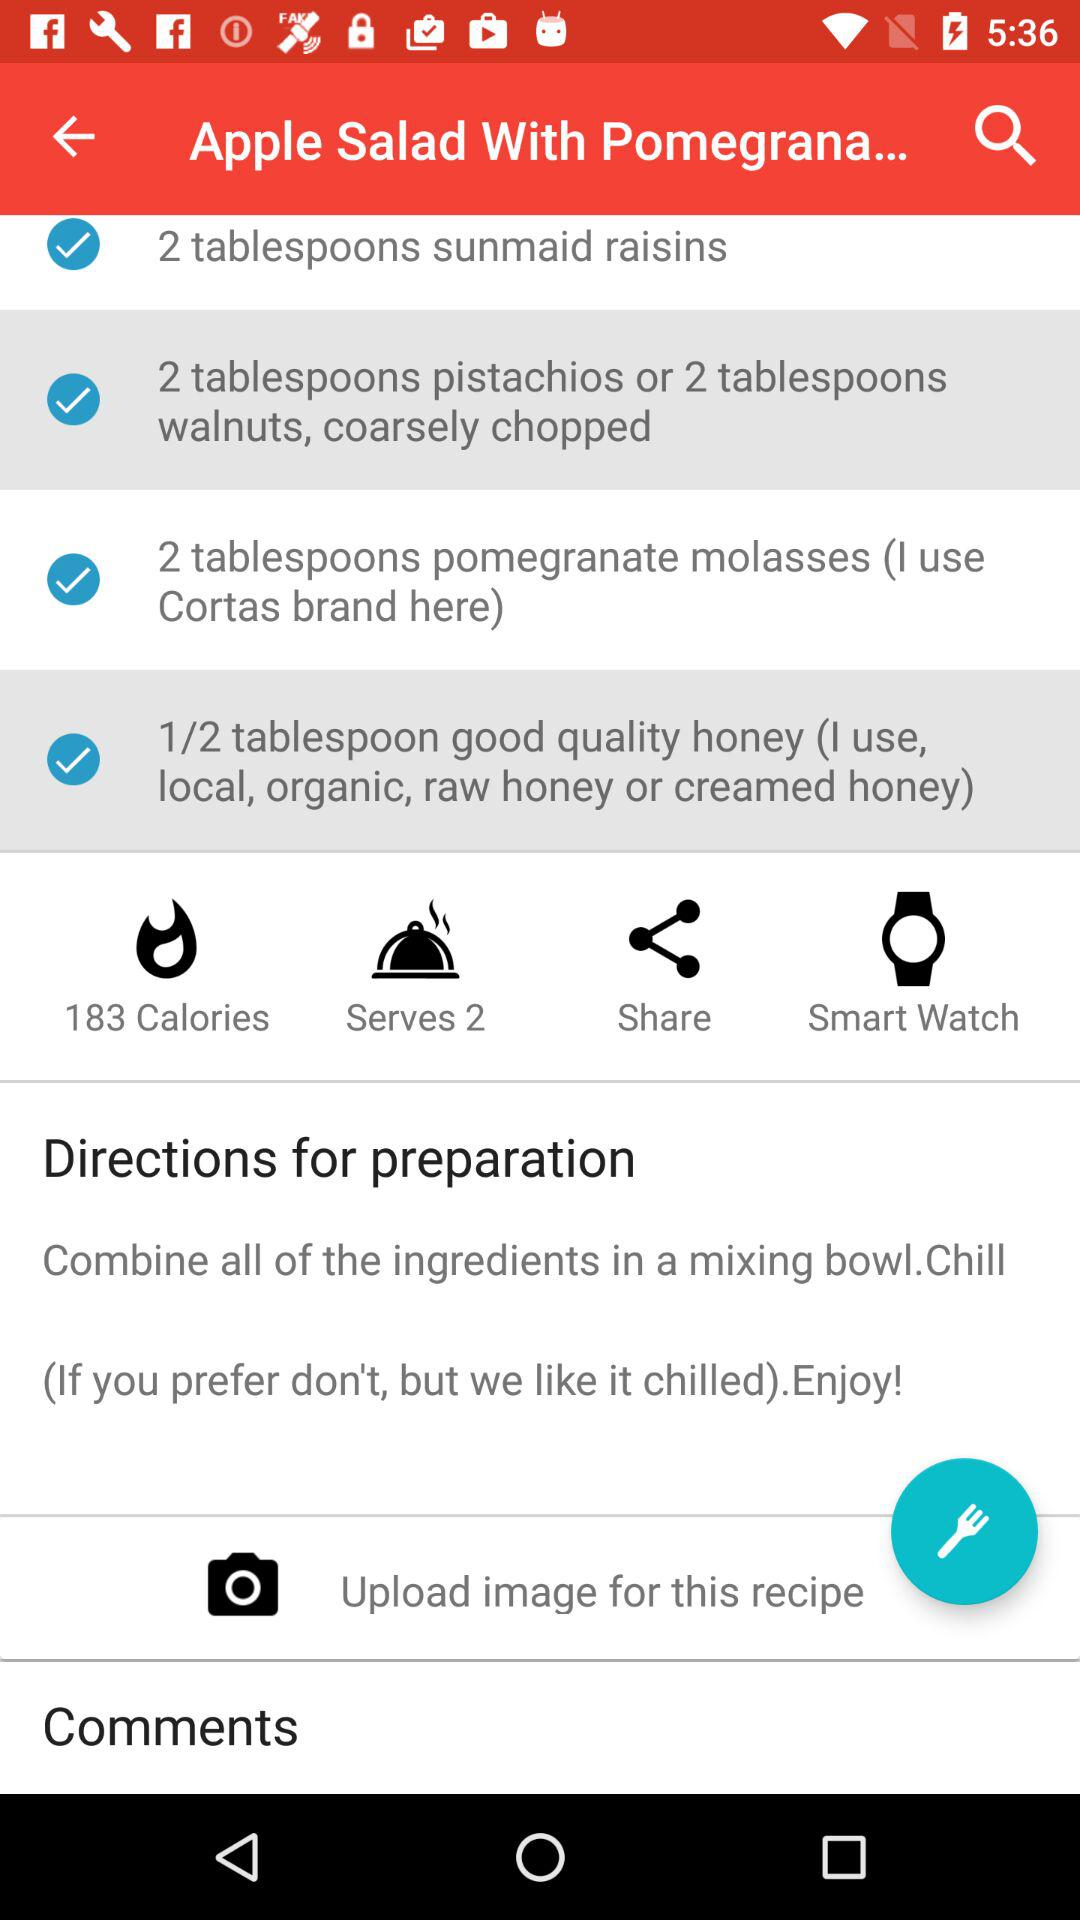What is the dish name? The dish name is "Apple Salad With Pomegrana...". 